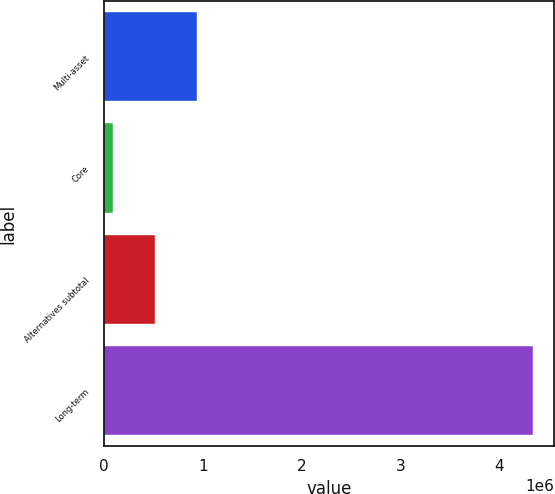Convert chart. <chart><loc_0><loc_0><loc_500><loc_500><bar_chart><fcel>Multi-asset<fcel>Core<fcel>Alternatives subtotal<fcel>Long-term<nl><fcel>940731<fcel>92085<fcel>516408<fcel>4.33532e+06<nl></chart> 